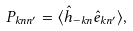<formula> <loc_0><loc_0><loc_500><loc_500>P _ { { k } n n ^ { \prime } } = \langle \hat { h } _ { - { k } n } \hat { e } _ { { k } n ^ { \prime } } \rangle ,</formula> 